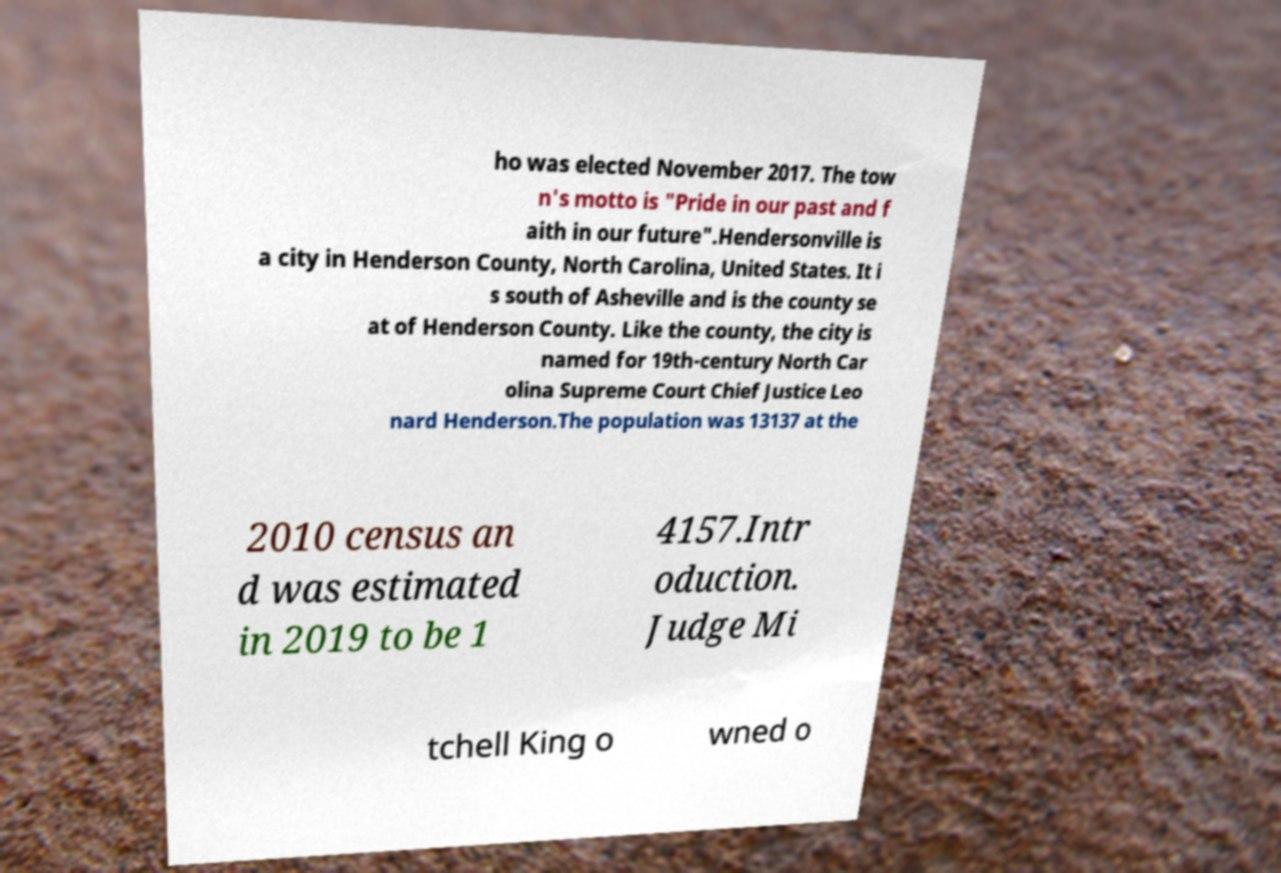Please read and relay the text visible in this image. What does it say? ho was elected November 2017. The tow n's motto is "Pride in our past and f aith in our future".Hendersonville is a city in Henderson County, North Carolina, United States. It i s south of Asheville and is the county se at of Henderson County. Like the county, the city is named for 19th-century North Car olina Supreme Court Chief Justice Leo nard Henderson.The population was 13137 at the 2010 census an d was estimated in 2019 to be 1 4157.Intr oduction. Judge Mi tchell King o wned o 